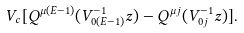Convert formula to latex. <formula><loc_0><loc_0><loc_500><loc_500>V _ { c } [ Q ^ { \mu ( E - 1 ) } ( V _ { 0 ( E - 1 ) } ^ { - 1 } z ) - Q ^ { \mu j } ( V _ { 0 j } ^ { - 1 } z ) ] .</formula> 